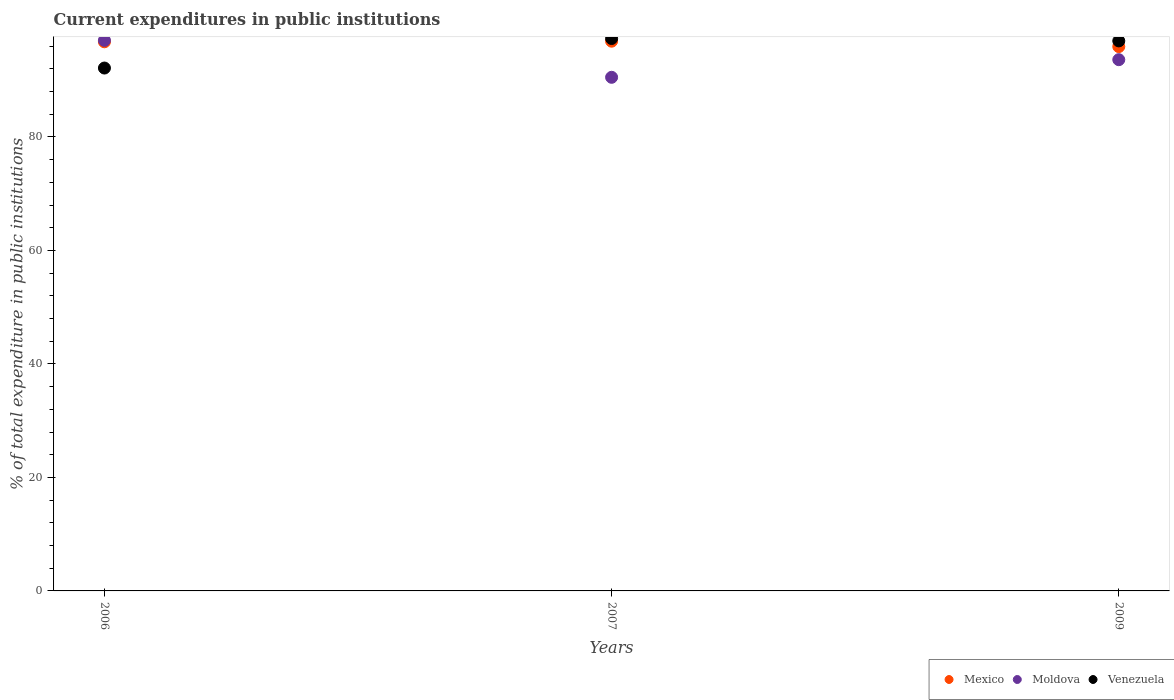What is the current expenditures in public institutions in Moldova in 2007?
Your answer should be very brief. 90.51. Across all years, what is the maximum current expenditures in public institutions in Mexico?
Provide a short and direct response. 96.87. Across all years, what is the minimum current expenditures in public institutions in Mexico?
Keep it short and to the point. 95.92. In which year was the current expenditures in public institutions in Mexico minimum?
Provide a succinct answer. 2009. What is the total current expenditures in public institutions in Moldova in the graph?
Provide a succinct answer. 281.13. What is the difference between the current expenditures in public institutions in Mexico in 2006 and that in 2009?
Offer a very short reply. 0.84. What is the difference between the current expenditures in public institutions in Mexico in 2006 and the current expenditures in public institutions in Moldova in 2007?
Offer a very short reply. 6.26. What is the average current expenditures in public institutions in Mexico per year?
Your response must be concise. 96.52. In the year 2009, what is the difference between the current expenditures in public institutions in Moldova and current expenditures in public institutions in Mexico?
Your answer should be compact. -2.31. What is the ratio of the current expenditures in public institutions in Moldova in 2006 to that in 2009?
Your answer should be compact. 1.04. Is the current expenditures in public institutions in Moldova in 2006 less than that in 2009?
Your answer should be compact. No. What is the difference between the highest and the second highest current expenditures in public institutions in Mexico?
Provide a succinct answer. 0.11. What is the difference between the highest and the lowest current expenditures in public institutions in Moldova?
Your answer should be very brief. 6.51. Is it the case that in every year, the sum of the current expenditures in public institutions in Mexico and current expenditures in public institutions in Moldova  is greater than the current expenditures in public institutions in Venezuela?
Your response must be concise. Yes. Is the current expenditures in public institutions in Venezuela strictly less than the current expenditures in public institutions in Moldova over the years?
Offer a terse response. No. Does the graph contain any zero values?
Provide a succinct answer. No. How are the legend labels stacked?
Your answer should be very brief. Horizontal. What is the title of the graph?
Offer a very short reply. Current expenditures in public institutions. What is the label or title of the X-axis?
Make the answer very short. Years. What is the label or title of the Y-axis?
Offer a terse response. % of total expenditure in public institutions. What is the % of total expenditure in public institutions in Mexico in 2006?
Offer a very short reply. 96.76. What is the % of total expenditure in public institutions of Moldova in 2006?
Your answer should be compact. 97.02. What is the % of total expenditure in public institutions of Venezuela in 2006?
Your answer should be very brief. 92.14. What is the % of total expenditure in public institutions of Mexico in 2007?
Offer a terse response. 96.87. What is the % of total expenditure in public institutions of Moldova in 2007?
Provide a succinct answer. 90.51. What is the % of total expenditure in public institutions of Venezuela in 2007?
Ensure brevity in your answer.  97.34. What is the % of total expenditure in public institutions in Mexico in 2009?
Provide a short and direct response. 95.92. What is the % of total expenditure in public institutions of Moldova in 2009?
Give a very brief answer. 93.61. What is the % of total expenditure in public institutions in Venezuela in 2009?
Ensure brevity in your answer.  96.92. Across all years, what is the maximum % of total expenditure in public institutions of Mexico?
Your answer should be very brief. 96.87. Across all years, what is the maximum % of total expenditure in public institutions of Moldova?
Provide a succinct answer. 97.02. Across all years, what is the maximum % of total expenditure in public institutions in Venezuela?
Keep it short and to the point. 97.34. Across all years, what is the minimum % of total expenditure in public institutions in Mexico?
Provide a succinct answer. 95.92. Across all years, what is the minimum % of total expenditure in public institutions in Moldova?
Provide a short and direct response. 90.51. Across all years, what is the minimum % of total expenditure in public institutions of Venezuela?
Give a very brief answer. 92.14. What is the total % of total expenditure in public institutions of Mexico in the graph?
Ensure brevity in your answer.  289.55. What is the total % of total expenditure in public institutions of Moldova in the graph?
Keep it short and to the point. 281.13. What is the total % of total expenditure in public institutions in Venezuela in the graph?
Give a very brief answer. 286.4. What is the difference between the % of total expenditure in public institutions of Mexico in 2006 and that in 2007?
Ensure brevity in your answer.  -0.11. What is the difference between the % of total expenditure in public institutions of Moldova in 2006 and that in 2007?
Your answer should be compact. 6.51. What is the difference between the % of total expenditure in public institutions of Venezuela in 2006 and that in 2007?
Provide a short and direct response. -5.2. What is the difference between the % of total expenditure in public institutions in Mexico in 2006 and that in 2009?
Give a very brief answer. 0.84. What is the difference between the % of total expenditure in public institutions in Moldova in 2006 and that in 2009?
Your answer should be very brief. 3.41. What is the difference between the % of total expenditure in public institutions of Venezuela in 2006 and that in 2009?
Your response must be concise. -4.78. What is the difference between the % of total expenditure in public institutions of Mexico in 2007 and that in 2009?
Your answer should be compact. 0.95. What is the difference between the % of total expenditure in public institutions in Moldova in 2007 and that in 2009?
Your response must be concise. -3.1. What is the difference between the % of total expenditure in public institutions of Venezuela in 2007 and that in 2009?
Your response must be concise. 0.42. What is the difference between the % of total expenditure in public institutions of Mexico in 2006 and the % of total expenditure in public institutions of Moldova in 2007?
Your answer should be very brief. 6.26. What is the difference between the % of total expenditure in public institutions of Mexico in 2006 and the % of total expenditure in public institutions of Venezuela in 2007?
Your answer should be compact. -0.58. What is the difference between the % of total expenditure in public institutions in Moldova in 2006 and the % of total expenditure in public institutions in Venezuela in 2007?
Your response must be concise. -0.32. What is the difference between the % of total expenditure in public institutions in Mexico in 2006 and the % of total expenditure in public institutions in Moldova in 2009?
Your answer should be compact. 3.15. What is the difference between the % of total expenditure in public institutions in Mexico in 2006 and the % of total expenditure in public institutions in Venezuela in 2009?
Keep it short and to the point. -0.16. What is the difference between the % of total expenditure in public institutions in Moldova in 2006 and the % of total expenditure in public institutions in Venezuela in 2009?
Provide a succinct answer. 0.1. What is the difference between the % of total expenditure in public institutions in Mexico in 2007 and the % of total expenditure in public institutions in Moldova in 2009?
Make the answer very short. 3.26. What is the difference between the % of total expenditure in public institutions of Mexico in 2007 and the % of total expenditure in public institutions of Venezuela in 2009?
Your response must be concise. -0.05. What is the difference between the % of total expenditure in public institutions in Moldova in 2007 and the % of total expenditure in public institutions in Venezuela in 2009?
Make the answer very short. -6.41. What is the average % of total expenditure in public institutions of Mexico per year?
Offer a terse response. 96.52. What is the average % of total expenditure in public institutions in Moldova per year?
Offer a terse response. 93.71. What is the average % of total expenditure in public institutions of Venezuela per year?
Provide a short and direct response. 95.47. In the year 2006, what is the difference between the % of total expenditure in public institutions in Mexico and % of total expenditure in public institutions in Moldova?
Offer a very short reply. -0.25. In the year 2006, what is the difference between the % of total expenditure in public institutions of Mexico and % of total expenditure in public institutions of Venezuela?
Provide a succinct answer. 4.63. In the year 2006, what is the difference between the % of total expenditure in public institutions in Moldova and % of total expenditure in public institutions in Venezuela?
Provide a short and direct response. 4.88. In the year 2007, what is the difference between the % of total expenditure in public institutions in Mexico and % of total expenditure in public institutions in Moldova?
Provide a short and direct response. 6.36. In the year 2007, what is the difference between the % of total expenditure in public institutions of Mexico and % of total expenditure in public institutions of Venezuela?
Your response must be concise. -0.47. In the year 2007, what is the difference between the % of total expenditure in public institutions of Moldova and % of total expenditure in public institutions of Venezuela?
Your answer should be very brief. -6.83. In the year 2009, what is the difference between the % of total expenditure in public institutions of Mexico and % of total expenditure in public institutions of Moldova?
Your response must be concise. 2.31. In the year 2009, what is the difference between the % of total expenditure in public institutions of Mexico and % of total expenditure in public institutions of Venezuela?
Give a very brief answer. -1. In the year 2009, what is the difference between the % of total expenditure in public institutions of Moldova and % of total expenditure in public institutions of Venezuela?
Offer a very short reply. -3.31. What is the ratio of the % of total expenditure in public institutions of Mexico in 2006 to that in 2007?
Give a very brief answer. 1. What is the ratio of the % of total expenditure in public institutions of Moldova in 2006 to that in 2007?
Ensure brevity in your answer.  1.07. What is the ratio of the % of total expenditure in public institutions in Venezuela in 2006 to that in 2007?
Make the answer very short. 0.95. What is the ratio of the % of total expenditure in public institutions of Mexico in 2006 to that in 2009?
Keep it short and to the point. 1.01. What is the ratio of the % of total expenditure in public institutions of Moldova in 2006 to that in 2009?
Offer a terse response. 1.04. What is the ratio of the % of total expenditure in public institutions in Venezuela in 2006 to that in 2009?
Your answer should be very brief. 0.95. What is the ratio of the % of total expenditure in public institutions in Mexico in 2007 to that in 2009?
Your response must be concise. 1.01. What is the ratio of the % of total expenditure in public institutions of Moldova in 2007 to that in 2009?
Your response must be concise. 0.97. What is the difference between the highest and the second highest % of total expenditure in public institutions of Mexico?
Provide a succinct answer. 0.11. What is the difference between the highest and the second highest % of total expenditure in public institutions of Moldova?
Provide a short and direct response. 3.41. What is the difference between the highest and the second highest % of total expenditure in public institutions in Venezuela?
Your answer should be compact. 0.42. What is the difference between the highest and the lowest % of total expenditure in public institutions in Mexico?
Ensure brevity in your answer.  0.95. What is the difference between the highest and the lowest % of total expenditure in public institutions in Moldova?
Provide a succinct answer. 6.51. What is the difference between the highest and the lowest % of total expenditure in public institutions in Venezuela?
Offer a terse response. 5.2. 